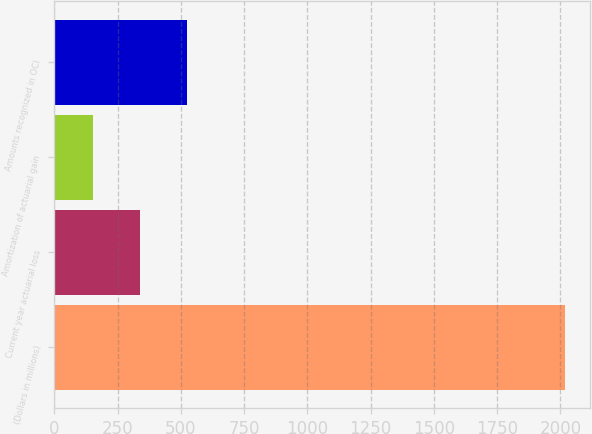<chart> <loc_0><loc_0><loc_500><loc_500><bar_chart><fcel>(Dollars in millions)<fcel>Current year actuarial loss<fcel>Amortization of actuarial gain<fcel>Amounts recognized in OCI<nl><fcel>2017<fcel>340.3<fcel>154<fcel>526.6<nl></chart> 